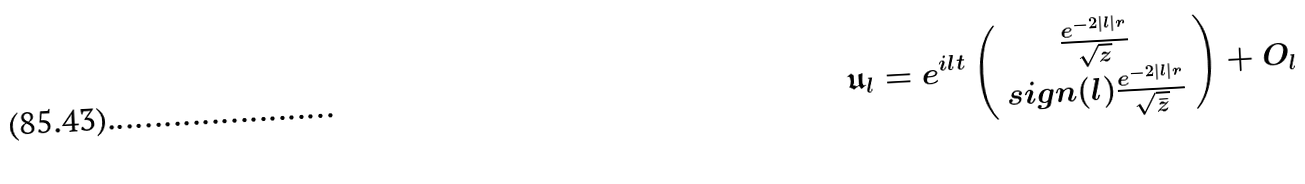Convert formula to latex. <formula><loc_0><loc_0><loc_500><loc_500>\mathfrak { u } _ { l } = e ^ { i l t } \left ( \begin{array} { c } \frac { e ^ { - 2 | l | r } } { \sqrt { z } } \\ s i g n ( l ) \frac { e ^ { - 2 | l | r } } { \sqrt { \bar { z } } } \end{array} \right ) + O _ { l }</formula> 